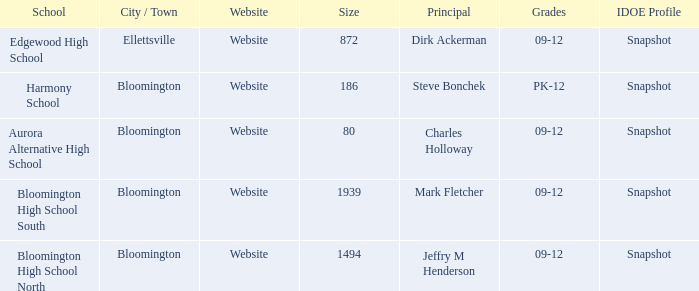Where's the school that Mark Fletcher is the principal of? Bloomington. Give me the full table as a dictionary. {'header': ['School', 'City / Town', 'Website', 'Size', 'Principal', 'Grades', 'IDOE Profile'], 'rows': [['Edgewood High School', 'Ellettsville', 'Website', '872', 'Dirk Ackerman', '09-12', 'Snapshot'], ['Harmony School', 'Bloomington', 'Website', '186', 'Steve Bonchek', 'PK-12', 'Snapshot'], ['Aurora Alternative High School', 'Bloomington', 'Website', '80', 'Charles Holloway', '09-12', 'Snapshot'], ['Bloomington High School South', 'Bloomington', 'Website', '1939', 'Mark Fletcher', '09-12', 'Snapshot'], ['Bloomington High School North', 'Bloomington', 'Website', '1494', 'Jeffry M Henderson', '09-12', 'Snapshot']]} 